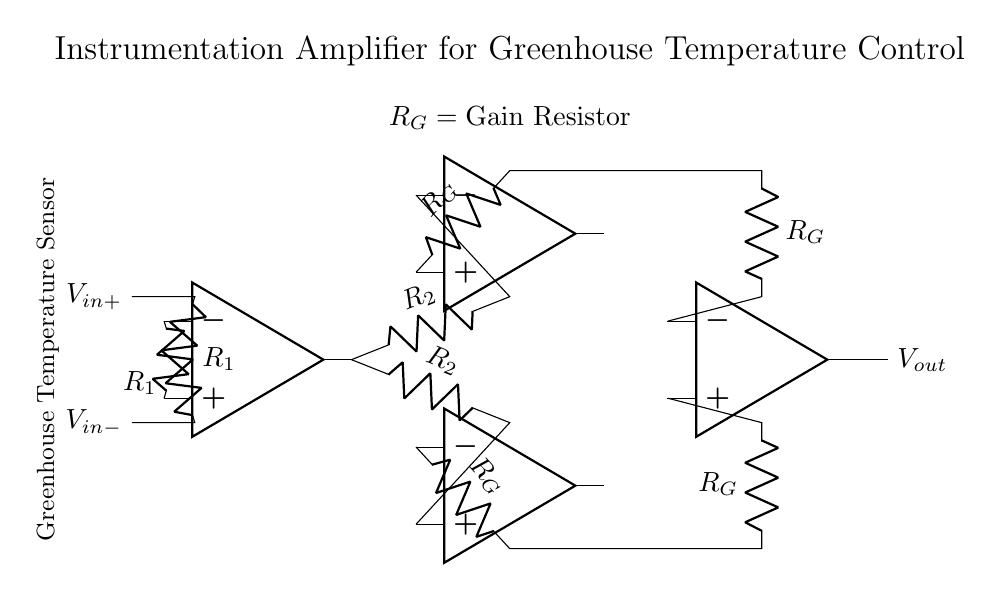what is the function of the operational amplifiers in this circuit? The operational amplifiers are used to amplify the differential input signal from the temperature sensor, allowing for better precision in temperature measurements. Each op-amp performs a specific function, including amplification and buffering.
Answer: amplification how many resistors are used in this instrumentation amplifier circuit? There are four resistors total: two identical resistors for input (R1), two feedback resistors (R2), and two gain resistors (RG), which contribute to the overall gain of the amplifier.
Answer: four what is the role of the gain resistor R_G in this circuit? The gain resistor R_G determines the amplification factor of the circuit. By adjusting its value, the gain can be set to suit the required temperature measurement precision for the greenhouse.
Answer: determines gain what kind of signal is inputted into the amplifier? The input signal is a differential voltage provided by a temperature sensor, which measures the temperature difference across its terminals.
Answer: differential voltage how does this circuit enable precise temperature control in greenhouse systems? This circuit enables precise temperature control by amplifying small temperature variations detected by the sensor, allowing for accurate adjustments in the greenhouse environment based on those measurements.
Answer: amplifies temperature variations what happens if R_G is increased in value? If R_G is increased, the gain of the amplifier increases, resulting in a larger output voltage for the same input differential voltage, thus improving sensitivity but possibly reducing stability.
Answer: increases gain what is the purpose of feedback resistors in this amplifier configuration? The feedback resistors are used to manage the circuit's stability and set the gain level, allowing the amplifier to operate effectively while preventing distortion of the output signal.
Answer: manage gain and stability 